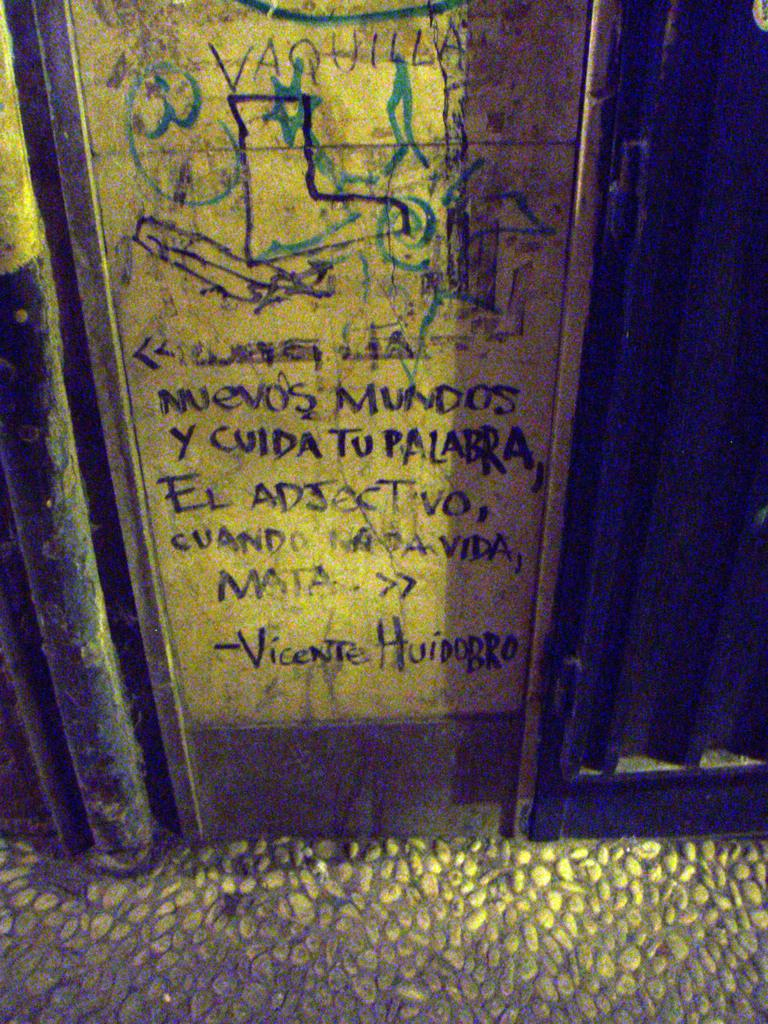<image>
Share a concise interpretation of the image provided. A sign in spanish referencing Vicente Huidobro reads "Nuevos Mundos y cuida tu palabra, El Adjectivo, cuando nada vida, matar. 